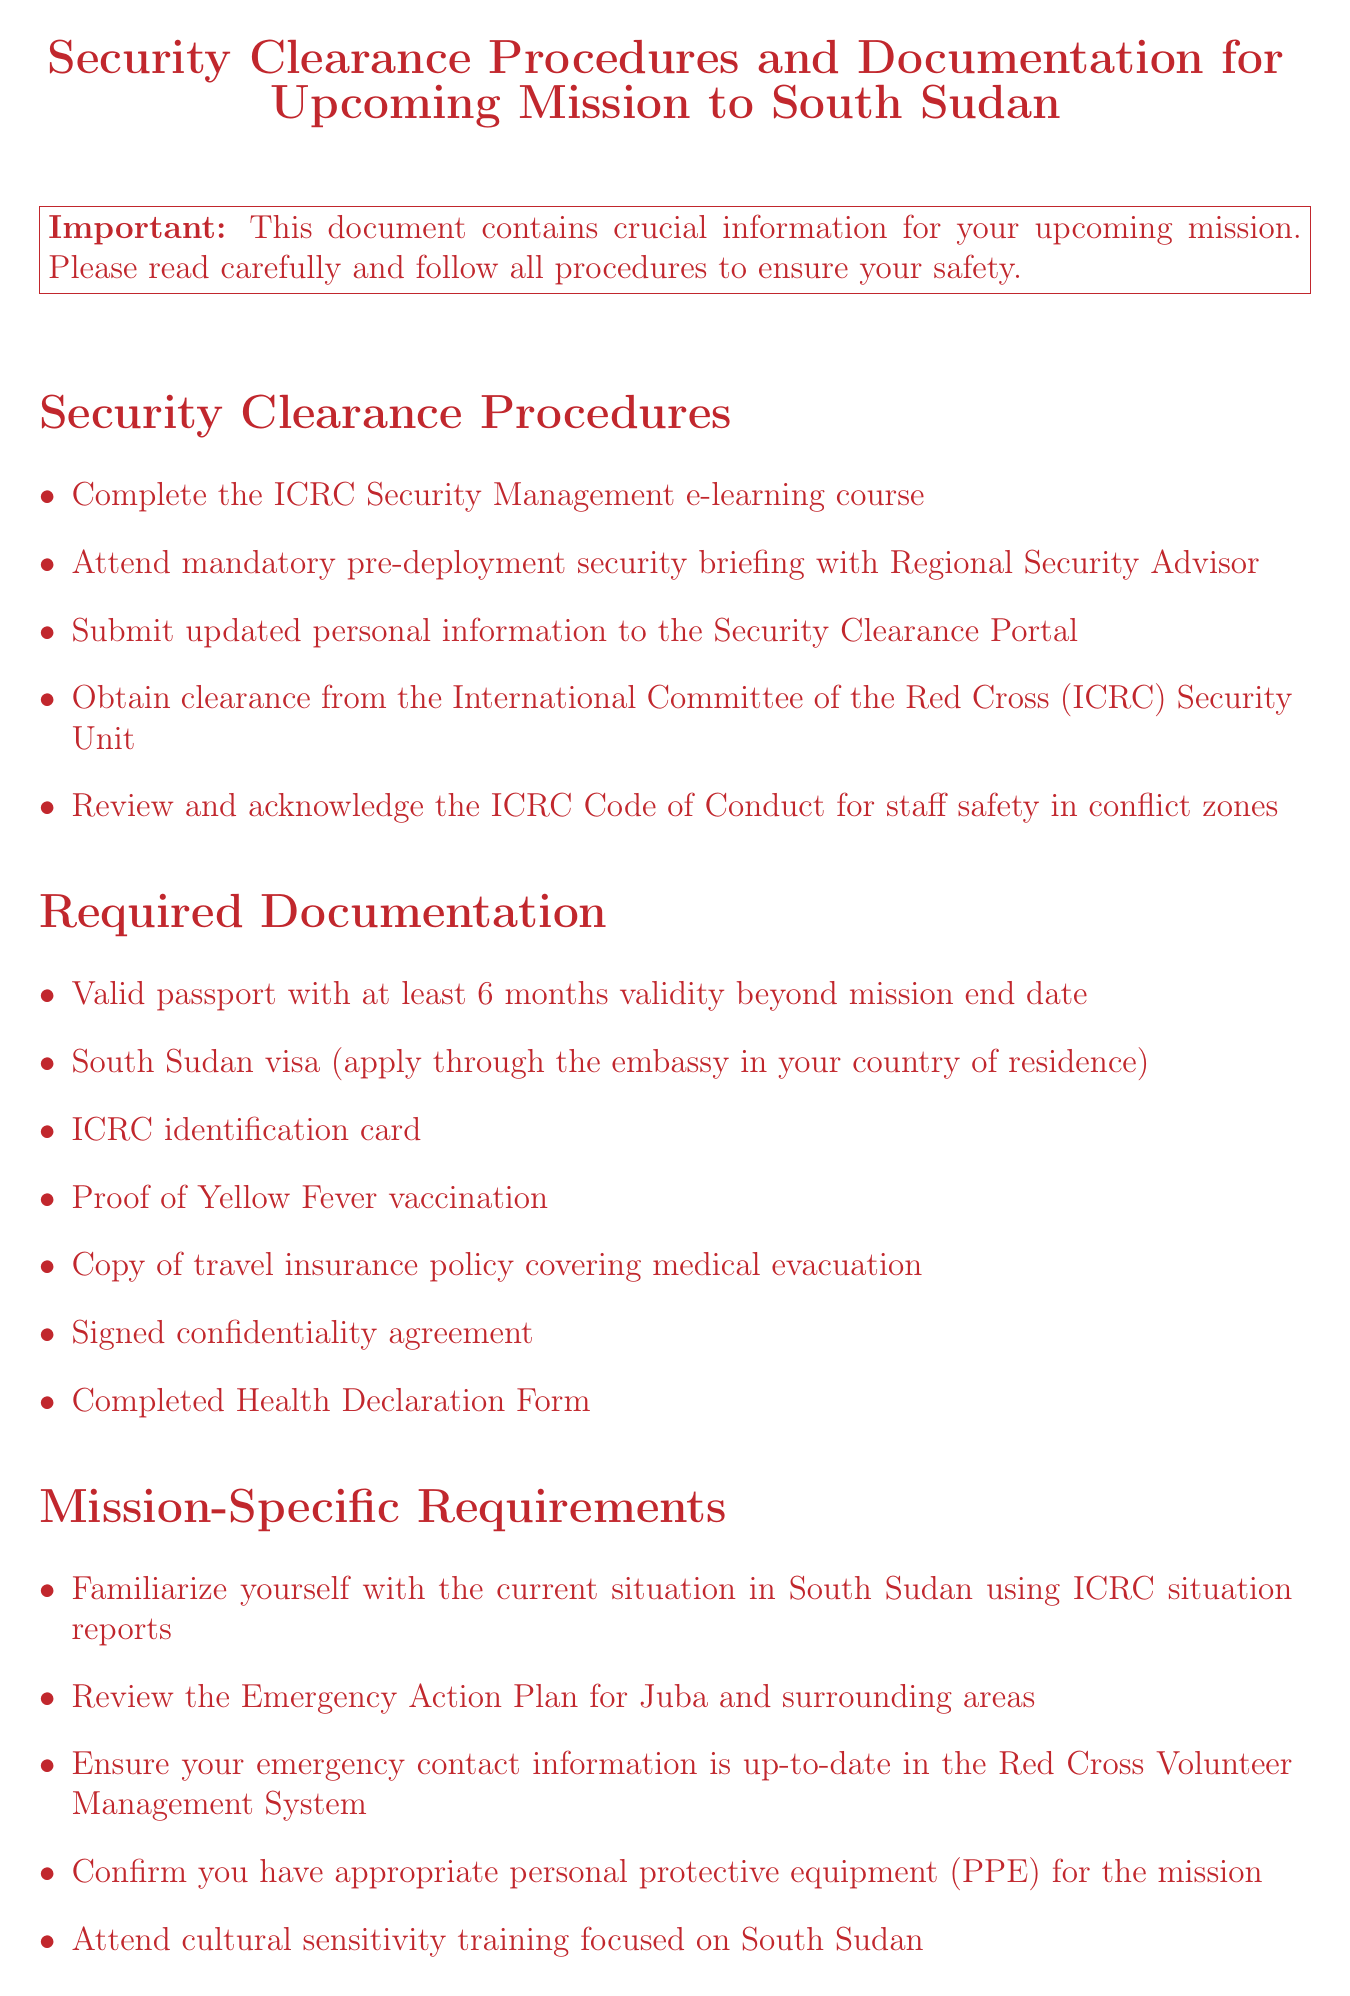What is the title of the memo? The title is stated at the beginning of the memo, which serves to inform the reader about the purpose of the document.
Answer: Security Clearance Procedures and Documentation for Upcoming Mission to South Sudan How many items are listed under Security Clearance Procedures? The number of items can be counted from the bullet points under the Security Clearance Procedures section.
Answer: 5 What document must you complete regarding your health before deployment? This is mentioned under the Health and Safety Precautions, specifying a particular form required from the personnel before the mission.
Answer: Health Declaration Form What vaccination proof is required for the mission? This requirement is noted under the Required Documentation, explicitly mentioning the type of vaccination needed before the mission.
Answer: Yellow Fever vaccination What is the primary concern mentioned in the closing remarks? The closing remarks highlight a specific aspect that the organization prioritizes for the safety of its personnel during missions.
Answer: Safety How should personal contact information be maintained? This guideline is stated under the Mission-Specific Requirements section, outlining how to keep personal contact details current.
Answer: Up-to-date in the Red Cross Volunteer Management System What must you do if you feel uncomfortable during the mission? This advice is included in the closing remarks, conveying the appropriate action to take in case of discomfort or safety concerns.
Answer: Communicate with your team leader Which equipment is necessary to confirm for the mission? This detail is referenced under Mission-Specific Requirements, indicating a particular set of items that must be ensured before the mission.
Answer: Personal protective equipment (PPE) 